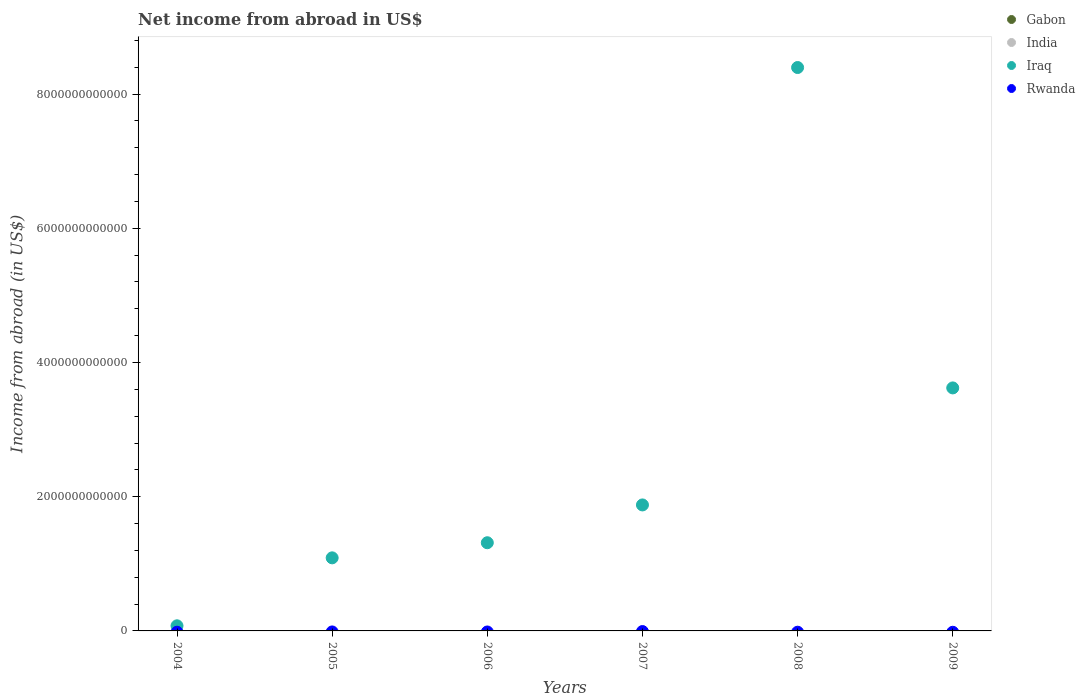Is the number of dotlines equal to the number of legend labels?
Provide a succinct answer. No. Across all years, what is the maximum net income from abroad in Iraq?
Keep it short and to the point. 8.40e+12. In which year was the net income from abroad in Iraq maximum?
Offer a terse response. 2008. What is the total net income from abroad in India in the graph?
Provide a succinct answer. 0. What is the difference between the net income from abroad in Iraq in 2005 and that in 2007?
Provide a short and direct response. -7.88e+11. What is the difference between the net income from abroad in Rwanda in 2004 and the net income from abroad in Iraq in 2009?
Offer a very short reply. -3.62e+12. In how many years, is the net income from abroad in Gabon greater than 400000000000 US$?
Give a very brief answer. 0. What is the ratio of the net income from abroad in Iraq in 2004 to that in 2006?
Ensure brevity in your answer.  0.06. Is the net income from abroad in Iraq in 2004 less than that in 2006?
Give a very brief answer. Yes. In how many years, is the net income from abroad in India greater than the average net income from abroad in India taken over all years?
Offer a very short reply. 0. Is it the case that in every year, the sum of the net income from abroad in Gabon and net income from abroad in Iraq  is greater than the sum of net income from abroad in India and net income from abroad in Rwanda?
Ensure brevity in your answer.  No. Is it the case that in every year, the sum of the net income from abroad in Rwanda and net income from abroad in India  is greater than the net income from abroad in Iraq?
Your response must be concise. No. Does the net income from abroad in Gabon monotonically increase over the years?
Your response must be concise. No. Is the net income from abroad in Iraq strictly greater than the net income from abroad in India over the years?
Offer a very short reply. Yes. Is the net income from abroad in India strictly less than the net income from abroad in Iraq over the years?
Your answer should be very brief. Yes. What is the difference between two consecutive major ticks on the Y-axis?
Your answer should be very brief. 2.00e+12. Are the values on the major ticks of Y-axis written in scientific E-notation?
Your answer should be very brief. No. Does the graph contain any zero values?
Your answer should be very brief. Yes. Does the graph contain grids?
Provide a succinct answer. No. Where does the legend appear in the graph?
Keep it short and to the point. Top right. How many legend labels are there?
Your answer should be very brief. 4. How are the legend labels stacked?
Offer a terse response. Vertical. What is the title of the graph?
Provide a succinct answer. Net income from abroad in US$. Does "East Asia (developing only)" appear as one of the legend labels in the graph?
Your answer should be very brief. No. What is the label or title of the Y-axis?
Provide a short and direct response. Income from abroad (in US$). What is the Income from abroad (in US$) of Gabon in 2004?
Give a very brief answer. 0. What is the Income from abroad (in US$) in Iraq in 2004?
Offer a terse response. 7.62e+1. What is the Income from abroad (in US$) in Rwanda in 2004?
Make the answer very short. 0. What is the Income from abroad (in US$) of Gabon in 2005?
Make the answer very short. 0. What is the Income from abroad (in US$) in Iraq in 2005?
Make the answer very short. 1.09e+12. What is the Income from abroad (in US$) in Gabon in 2006?
Make the answer very short. 0. What is the Income from abroad (in US$) in Iraq in 2006?
Provide a succinct answer. 1.31e+12. What is the Income from abroad (in US$) in Gabon in 2007?
Your answer should be compact. 0. What is the Income from abroad (in US$) in India in 2007?
Your answer should be very brief. 0. What is the Income from abroad (in US$) of Iraq in 2007?
Give a very brief answer. 1.88e+12. What is the Income from abroad (in US$) in Gabon in 2008?
Make the answer very short. 0. What is the Income from abroad (in US$) in India in 2008?
Offer a very short reply. 0. What is the Income from abroad (in US$) of Iraq in 2008?
Give a very brief answer. 8.40e+12. What is the Income from abroad (in US$) of Rwanda in 2008?
Keep it short and to the point. 0. What is the Income from abroad (in US$) in Gabon in 2009?
Keep it short and to the point. 0. What is the Income from abroad (in US$) of India in 2009?
Provide a short and direct response. 0. What is the Income from abroad (in US$) of Iraq in 2009?
Offer a very short reply. 3.62e+12. What is the Income from abroad (in US$) of Rwanda in 2009?
Your response must be concise. 0. Across all years, what is the maximum Income from abroad (in US$) in Iraq?
Give a very brief answer. 8.40e+12. Across all years, what is the minimum Income from abroad (in US$) of Iraq?
Offer a terse response. 7.62e+1. What is the total Income from abroad (in US$) in Gabon in the graph?
Make the answer very short. 0. What is the total Income from abroad (in US$) of Iraq in the graph?
Ensure brevity in your answer.  1.64e+13. What is the total Income from abroad (in US$) in Rwanda in the graph?
Give a very brief answer. 0. What is the difference between the Income from abroad (in US$) of Iraq in 2004 and that in 2005?
Offer a terse response. -1.01e+12. What is the difference between the Income from abroad (in US$) of Iraq in 2004 and that in 2006?
Provide a succinct answer. -1.24e+12. What is the difference between the Income from abroad (in US$) of Iraq in 2004 and that in 2007?
Provide a short and direct response. -1.80e+12. What is the difference between the Income from abroad (in US$) of Iraq in 2004 and that in 2008?
Your answer should be compact. -8.32e+12. What is the difference between the Income from abroad (in US$) in Iraq in 2004 and that in 2009?
Provide a succinct answer. -3.55e+12. What is the difference between the Income from abroad (in US$) of Iraq in 2005 and that in 2006?
Provide a succinct answer. -2.25e+11. What is the difference between the Income from abroad (in US$) of Iraq in 2005 and that in 2007?
Give a very brief answer. -7.88e+11. What is the difference between the Income from abroad (in US$) of Iraq in 2005 and that in 2008?
Ensure brevity in your answer.  -7.31e+12. What is the difference between the Income from abroad (in US$) of Iraq in 2005 and that in 2009?
Offer a terse response. -2.53e+12. What is the difference between the Income from abroad (in US$) in Iraq in 2006 and that in 2007?
Offer a very short reply. -5.63e+11. What is the difference between the Income from abroad (in US$) in Iraq in 2006 and that in 2008?
Your response must be concise. -7.08e+12. What is the difference between the Income from abroad (in US$) of Iraq in 2006 and that in 2009?
Offer a terse response. -2.31e+12. What is the difference between the Income from abroad (in US$) of Iraq in 2007 and that in 2008?
Provide a succinct answer. -6.52e+12. What is the difference between the Income from abroad (in US$) in Iraq in 2007 and that in 2009?
Your answer should be very brief. -1.74e+12. What is the difference between the Income from abroad (in US$) of Iraq in 2008 and that in 2009?
Your response must be concise. 4.77e+12. What is the average Income from abroad (in US$) of India per year?
Make the answer very short. 0. What is the average Income from abroad (in US$) of Iraq per year?
Your answer should be very brief. 2.73e+12. What is the average Income from abroad (in US$) of Rwanda per year?
Your answer should be compact. 0. What is the ratio of the Income from abroad (in US$) of Iraq in 2004 to that in 2005?
Keep it short and to the point. 0.07. What is the ratio of the Income from abroad (in US$) in Iraq in 2004 to that in 2006?
Offer a terse response. 0.06. What is the ratio of the Income from abroad (in US$) of Iraq in 2004 to that in 2007?
Give a very brief answer. 0.04. What is the ratio of the Income from abroad (in US$) in Iraq in 2004 to that in 2008?
Give a very brief answer. 0.01. What is the ratio of the Income from abroad (in US$) in Iraq in 2004 to that in 2009?
Provide a succinct answer. 0.02. What is the ratio of the Income from abroad (in US$) in Iraq in 2005 to that in 2006?
Offer a terse response. 0.83. What is the ratio of the Income from abroad (in US$) in Iraq in 2005 to that in 2007?
Give a very brief answer. 0.58. What is the ratio of the Income from abroad (in US$) in Iraq in 2005 to that in 2008?
Give a very brief answer. 0.13. What is the ratio of the Income from abroad (in US$) in Iraq in 2005 to that in 2009?
Make the answer very short. 0.3. What is the ratio of the Income from abroad (in US$) of Iraq in 2006 to that in 2007?
Provide a short and direct response. 0.7. What is the ratio of the Income from abroad (in US$) in Iraq in 2006 to that in 2008?
Your answer should be very brief. 0.16. What is the ratio of the Income from abroad (in US$) of Iraq in 2006 to that in 2009?
Give a very brief answer. 0.36. What is the ratio of the Income from abroad (in US$) in Iraq in 2007 to that in 2008?
Your answer should be compact. 0.22. What is the ratio of the Income from abroad (in US$) in Iraq in 2007 to that in 2009?
Your answer should be compact. 0.52. What is the ratio of the Income from abroad (in US$) of Iraq in 2008 to that in 2009?
Provide a short and direct response. 2.32. What is the difference between the highest and the second highest Income from abroad (in US$) in Iraq?
Make the answer very short. 4.77e+12. What is the difference between the highest and the lowest Income from abroad (in US$) in Iraq?
Provide a succinct answer. 8.32e+12. 